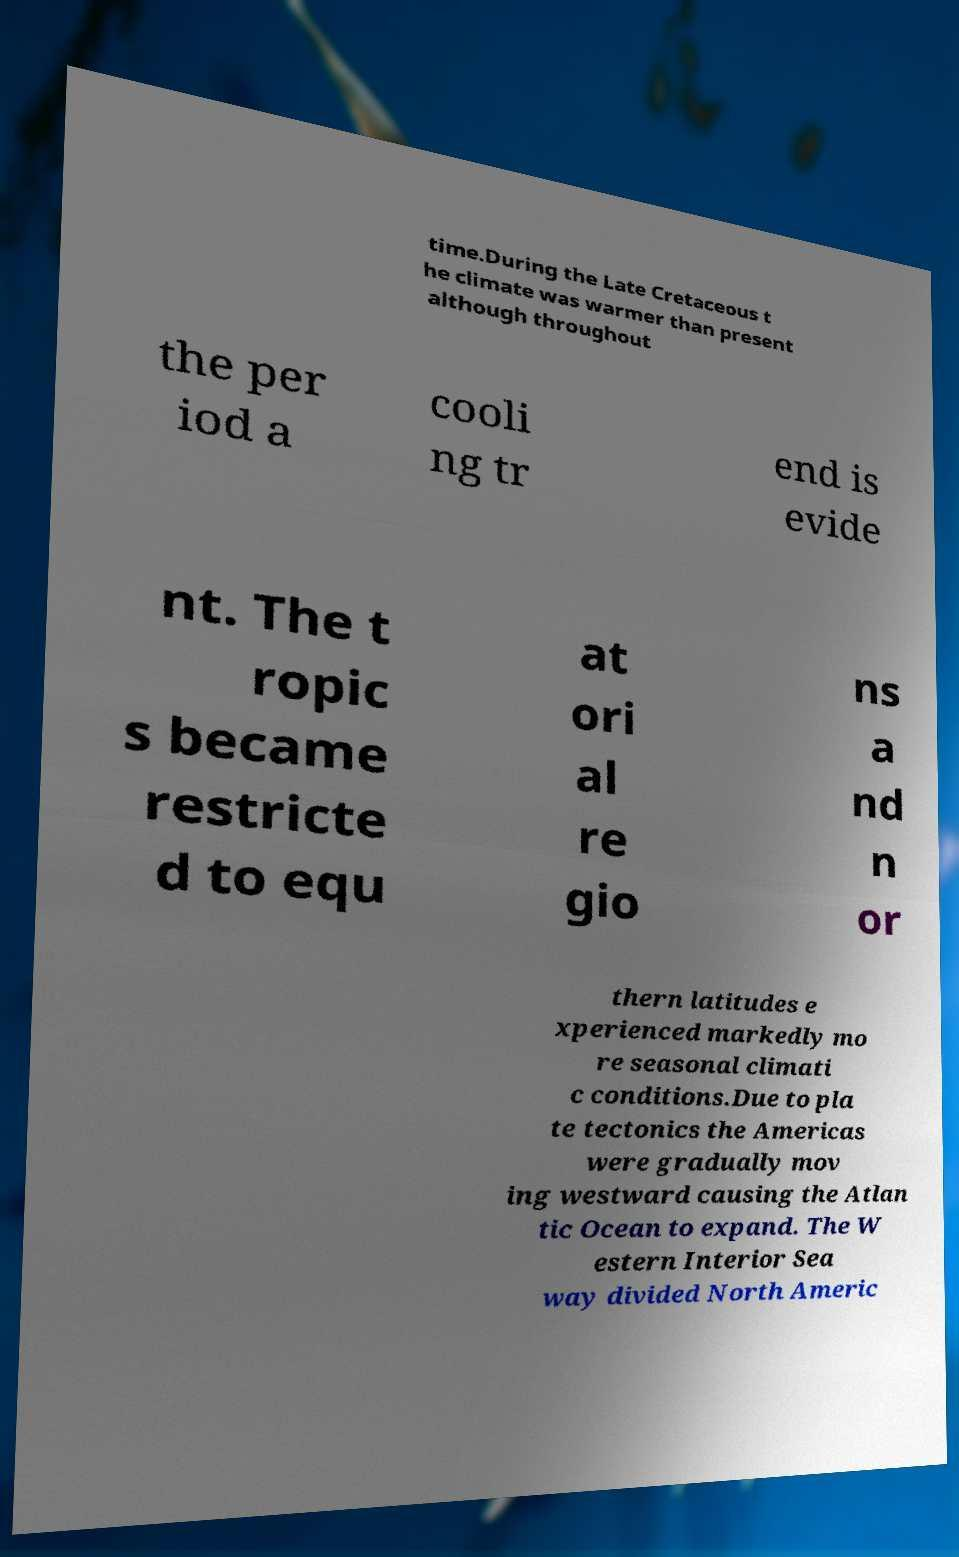What messages or text are displayed in this image? I need them in a readable, typed format. time.During the Late Cretaceous t he climate was warmer than present although throughout the per iod a cooli ng tr end is evide nt. The t ropic s became restricte d to equ at ori al re gio ns a nd n or thern latitudes e xperienced markedly mo re seasonal climati c conditions.Due to pla te tectonics the Americas were gradually mov ing westward causing the Atlan tic Ocean to expand. The W estern Interior Sea way divided North Americ 